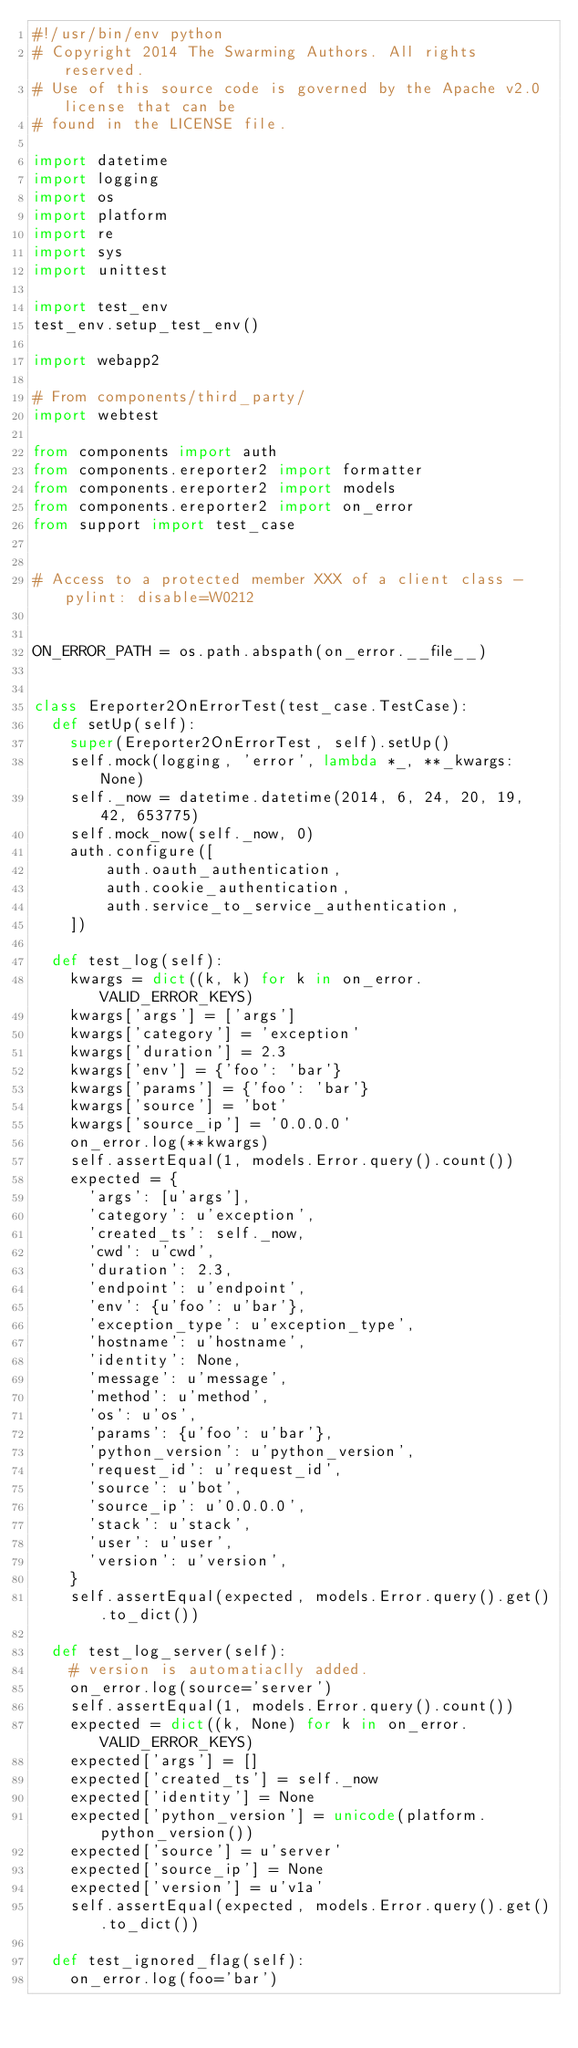<code> <loc_0><loc_0><loc_500><loc_500><_Python_>#!/usr/bin/env python
# Copyright 2014 The Swarming Authors. All rights reserved.
# Use of this source code is governed by the Apache v2.0 license that can be
# found in the LICENSE file.

import datetime
import logging
import os
import platform
import re
import sys
import unittest

import test_env
test_env.setup_test_env()

import webapp2

# From components/third_party/
import webtest

from components import auth
from components.ereporter2 import formatter
from components.ereporter2 import models
from components.ereporter2 import on_error
from support import test_case


# Access to a protected member XXX of a client class - pylint: disable=W0212


ON_ERROR_PATH = os.path.abspath(on_error.__file__)


class Ereporter2OnErrorTest(test_case.TestCase):
  def setUp(self):
    super(Ereporter2OnErrorTest, self).setUp()
    self.mock(logging, 'error', lambda *_, **_kwargs: None)
    self._now = datetime.datetime(2014, 6, 24, 20, 19, 42, 653775)
    self.mock_now(self._now, 0)
    auth.configure([
        auth.oauth_authentication,
        auth.cookie_authentication,
        auth.service_to_service_authentication,
    ])

  def test_log(self):
    kwargs = dict((k, k) for k in on_error.VALID_ERROR_KEYS)
    kwargs['args'] = ['args']
    kwargs['category'] = 'exception'
    kwargs['duration'] = 2.3
    kwargs['env'] = {'foo': 'bar'}
    kwargs['params'] = {'foo': 'bar'}
    kwargs['source'] = 'bot'
    kwargs['source_ip'] = '0.0.0.0'
    on_error.log(**kwargs)
    self.assertEqual(1, models.Error.query().count())
    expected = {
      'args': [u'args'],
      'category': u'exception',
      'created_ts': self._now,
      'cwd': u'cwd',
      'duration': 2.3,
      'endpoint': u'endpoint',
      'env': {u'foo': u'bar'},
      'exception_type': u'exception_type',
      'hostname': u'hostname',
      'identity': None,
      'message': u'message',
      'method': u'method',
      'os': u'os',
      'params': {u'foo': u'bar'},
      'python_version': u'python_version',
      'request_id': u'request_id',
      'source': u'bot',
      'source_ip': u'0.0.0.0',
      'stack': u'stack',
      'user': u'user',
      'version': u'version',
    }
    self.assertEqual(expected, models.Error.query().get().to_dict())

  def test_log_server(self):
    # version is automatiaclly added.
    on_error.log(source='server')
    self.assertEqual(1, models.Error.query().count())
    expected = dict((k, None) for k in on_error.VALID_ERROR_KEYS)
    expected['args'] = []
    expected['created_ts'] = self._now
    expected['identity'] = None
    expected['python_version'] = unicode(platform.python_version())
    expected['source'] = u'server'
    expected['source_ip'] = None
    expected['version'] = u'v1a'
    self.assertEqual(expected, models.Error.query().get().to_dict())

  def test_ignored_flag(self):
    on_error.log(foo='bar')</code> 